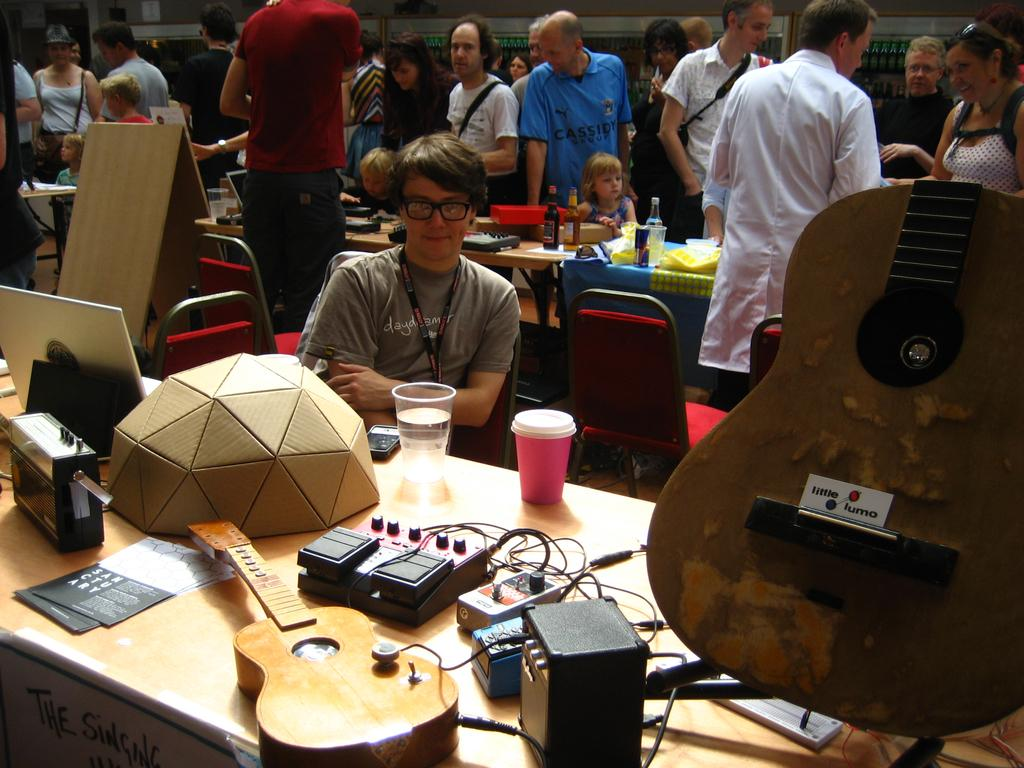What are the people in the image doing? The people in the image are sitting and standing. What object is on the table in the image? There is a guitar and a glass on the table in the image. Can you describe any electronic devices in the image? Yes, there is a mobile phone in the image. What type of underwear is the person wearing in the image? There is no information about the person's underwear in the image. Can you see any cows in the image? No, there are no cows present in the image. 